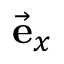<formula> <loc_0><loc_0><loc_500><loc_500>\vec { e } _ { x }</formula> 